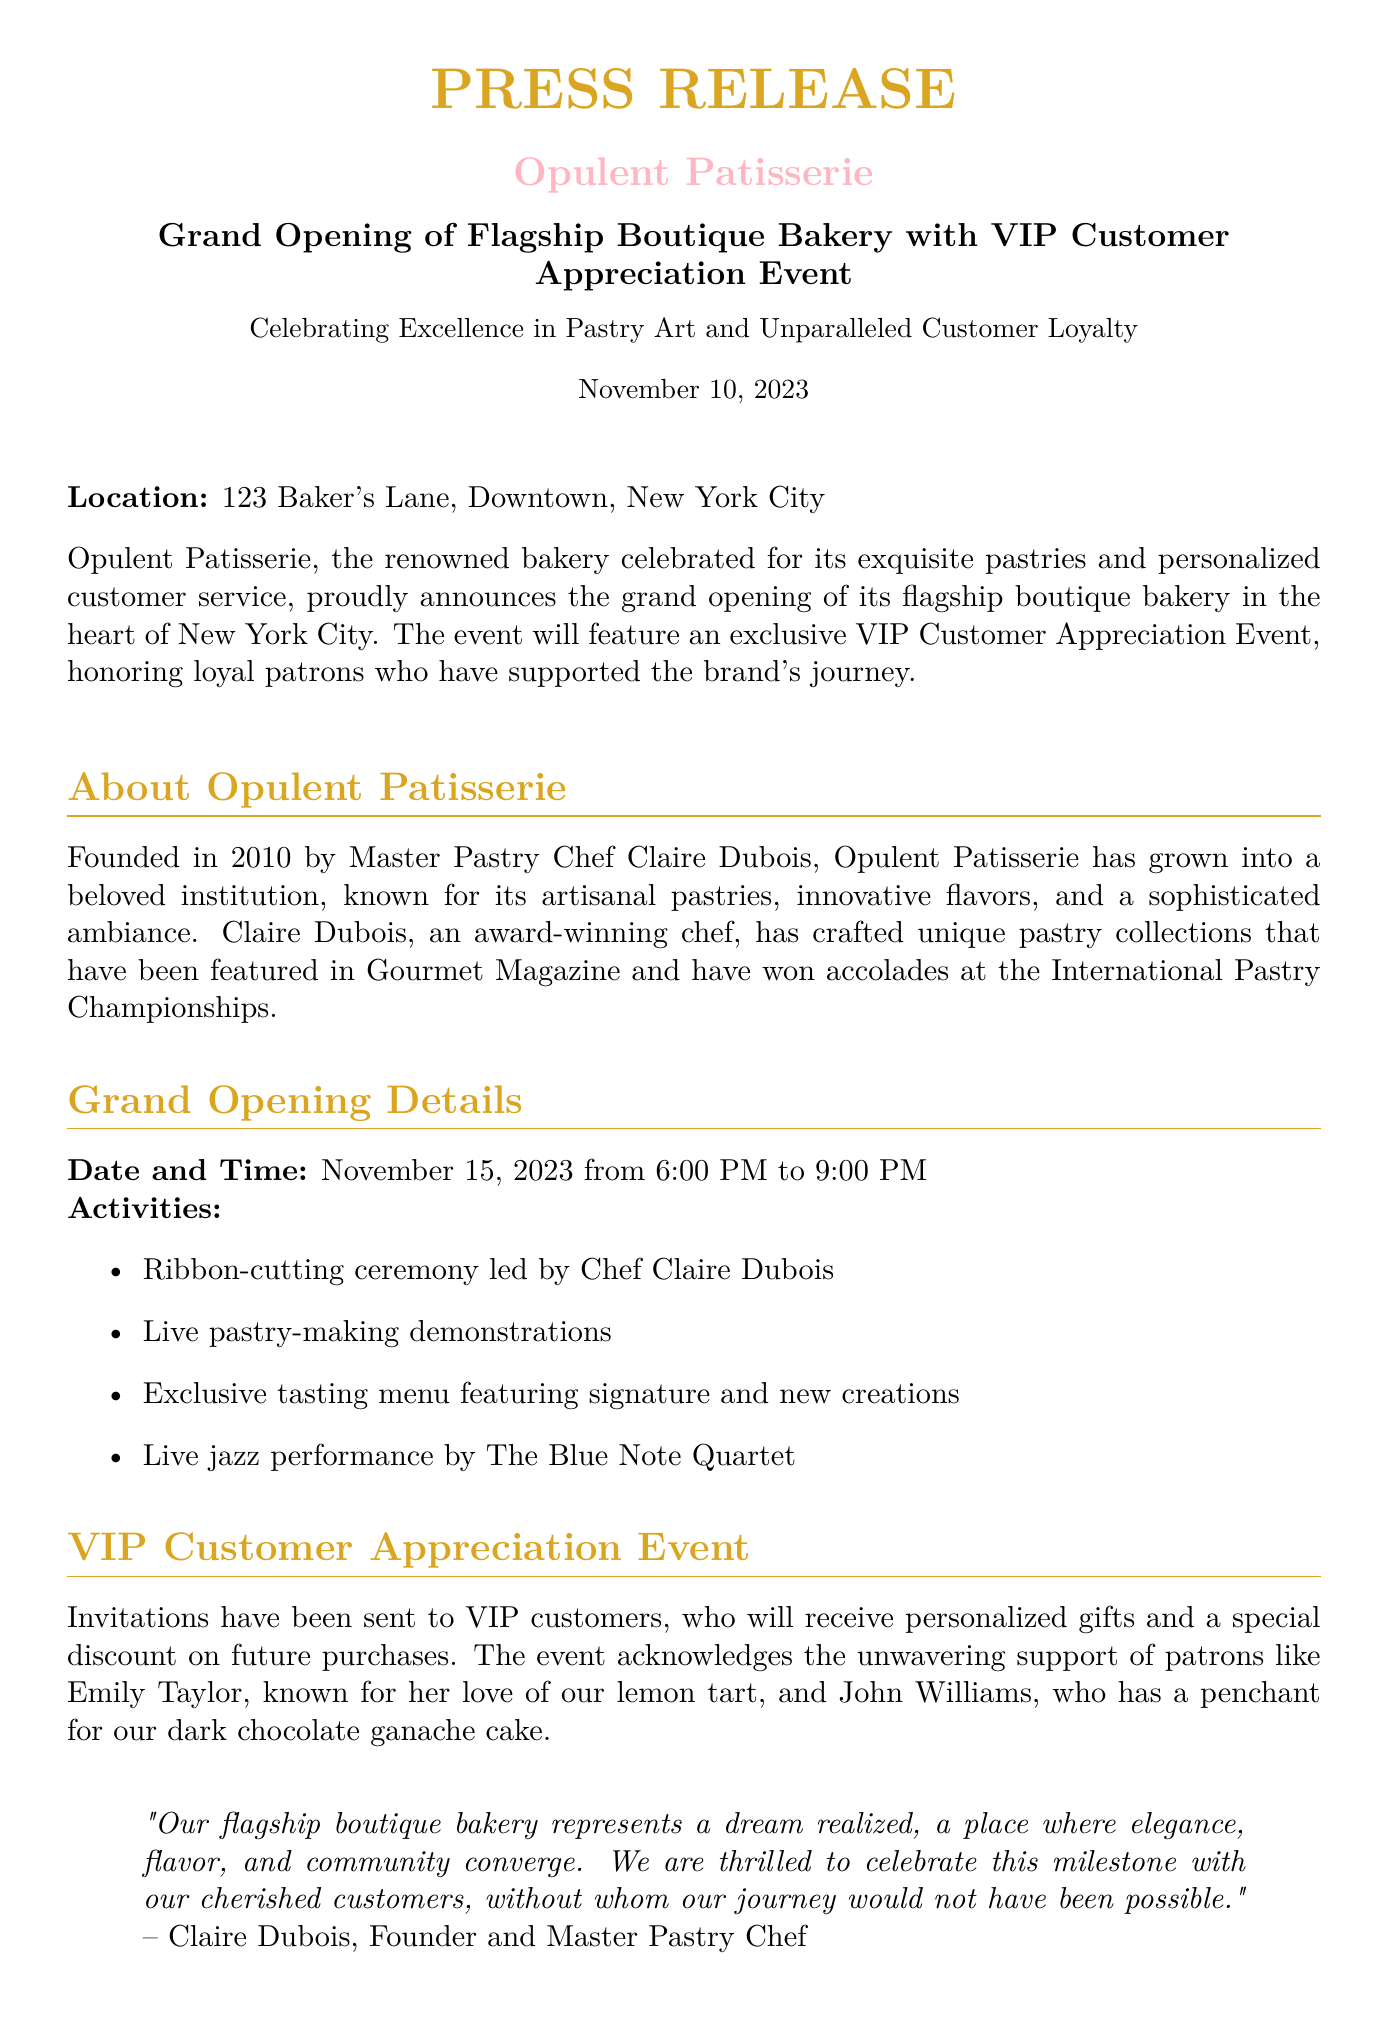What is the location of the flagship bakery? The location is mentioned in the document as 123 Baker's Lane, Downtown, New York City.
Answer: 123 Baker's Lane, Downtown, New York City What date is the grand opening event? The grand opening date is explicitly stated in the document as November 15, 2023.
Answer: November 15, 2023 Who is the founder of Opulent Patisserie? The document identifies Claire Dubois as the founder of Opulent Patisserie.
Answer: Claire Dubois What type of performance will occur at the grand opening? The document mentions a live jazz performance by The Blue Note Quartet.
Answer: Live jazz performance by The Blue Note Quartet What personalized gifts will VIP customers receive? The document states that VIP customers will receive personalized gifts as part of the event activities.
Answer: Personalized gifts How long will the grand opening event last? The document states that the grand opening will take place from 6:00 PM to 9:00 PM, which is a span of three hours.
Answer: Three hours What has been highlighted about the atmosphere of the new bakery? The press release emphasizes that the flagship boutique bakery is a place where elegance, flavor, and community converge.
Answer: Elegance, flavor, and community Who expressed excitement about the grand opening in the document? Sarah Thompson is quoted in the document expressing delight about the grand opening.
Answer: Sarah Thompson 